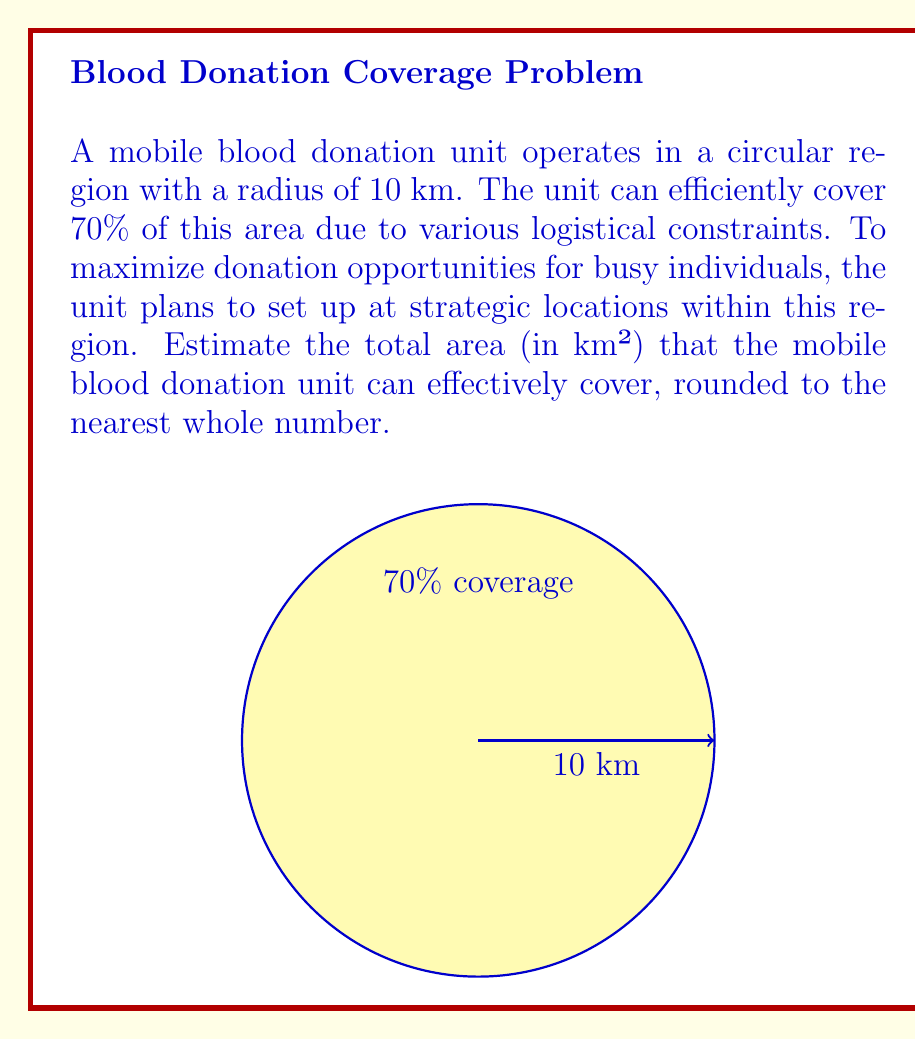Help me with this question. Let's approach this step-by-step:

1) First, we need to calculate the total area of the circular region:
   The formula for the area of a circle is $A = \pi r^2$
   where $r$ is the radius.

2) Given radius = 10 km:
   $A = \pi (10)^2 = 100\pi$ km²

3) The mobile unit can efficiently cover 70% of this area:
   Efficient coverage = $100\pi \times 0.70 = 70\pi$ km²

4) Now we need to calculate $70\pi$:
   $70\pi \approx 219.91$ km²

5) Rounding to the nearest whole number:
   $219.91$ rounds to $220$ km²

Therefore, the mobile blood donation unit can effectively cover approximately 220 km².
Answer: 220 km² 